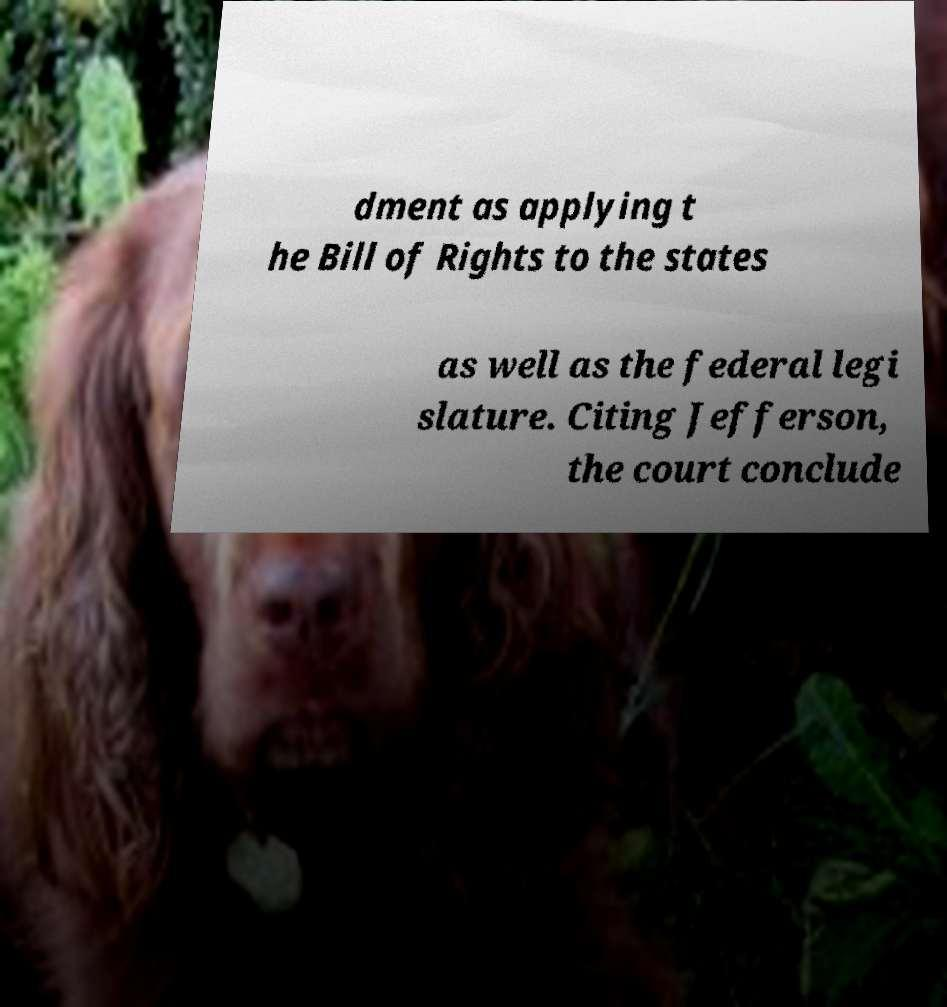Can you accurately transcribe the text from the provided image for me? dment as applying t he Bill of Rights to the states as well as the federal legi slature. Citing Jefferson, the court conclude 